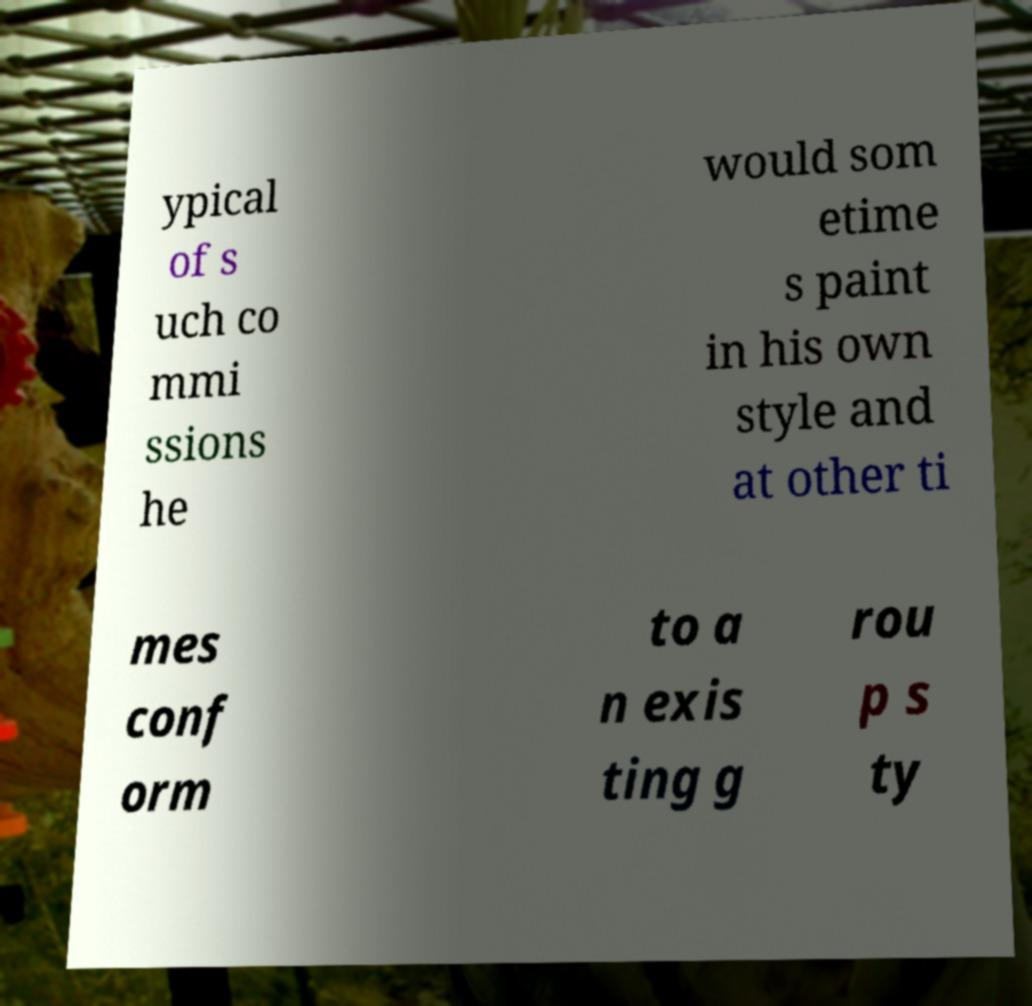Please identify and transcribe the text found in this image. ypical of s uch co mmi ssions he would som etime s paint in his own style and at other ti mes conf orm to a n exis ting g rou p s ty 